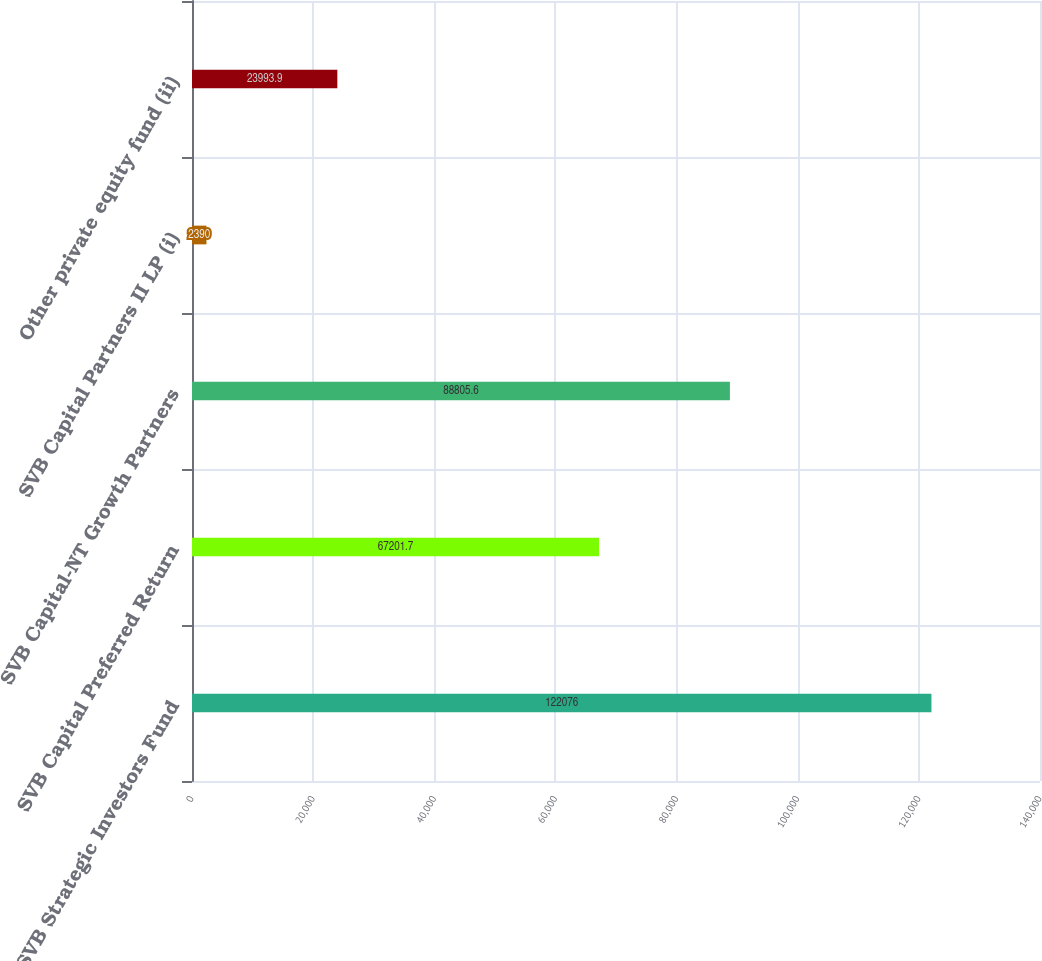Convert chart. <chart><loc_0><loc_0><loc_500><loc_500><bar_chart><fcel>SVB Strategic Investors Fund<fcel>SVB Capital Preferred Return<fcel>SVB Capital-NT Growth Partners<fcel>SVB Capital Partners II LP (i)<fcel>Other private equity fund (ii)<nl><fcel>122076<fcel>67201.7<fcel>88805.6<fcel>2390<fcel>23993.9<nl></chart> 